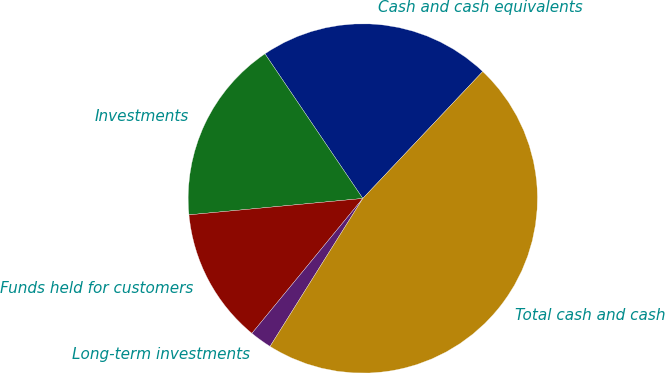Convert chart. <chart><loc_0><loc_0><loc_500><loc_500><pie_chart><fcel>Cash and cash equivalents<fcel>Investments<fcel>Funds held for customers<fcel>Long-term investments<fcel>Total cash and cash<nl><fcel>21.51%<fcel>17.03%<fcel>12.55%<fcel>2.04%<fcel>46.86%<nl></chart> 